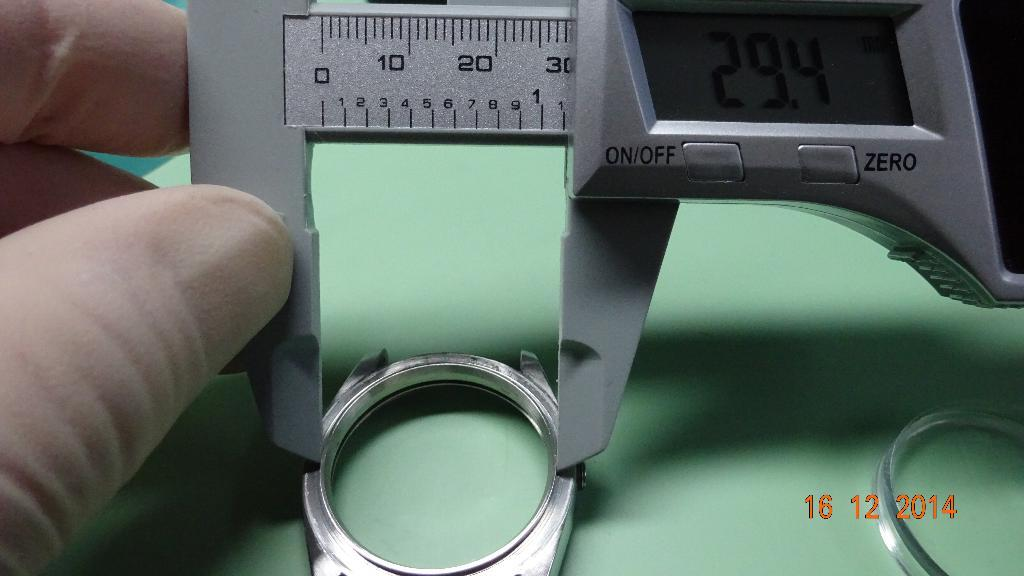<image>
Summarize the visual content of the image. A caliper with a digital measurement showing 29.4 